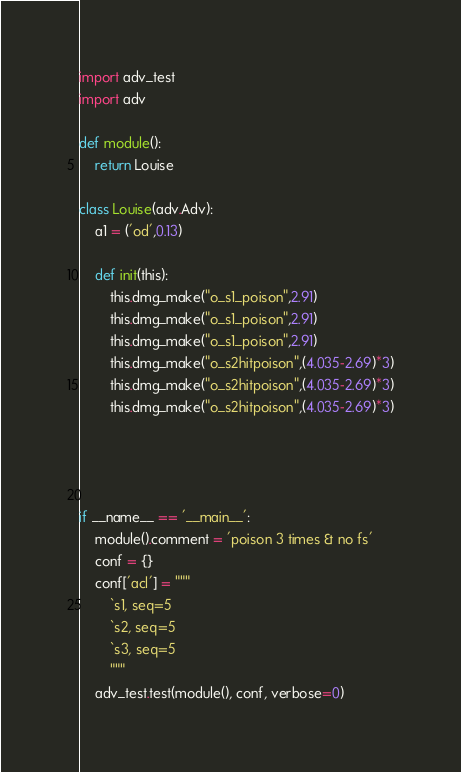<code> <loc_0><loc_0><loc_500><loc_500><_Python_>import adv_test
import adv

def module():
    return Louise

class Louise(adv.Adv):
    a1 = ('od',0.13)

    def init(this):
        this.dmg_make("o_s1_poison",2.91)
        this.dmg_make("o_s1_poison",2.91)
        this.dmg_make("o_s1_poison",2.91)
        this.dmg_make("o_s2hitpoison",(4.035-2.69)*3)
        this.dmg_make("o_s2hitpoison",(4.035-2.69)*3)
        this.dmg_make("o_s2hitpoison",(4.035-2.69)*3)




if __name__ == '__main__':
    module().comment = 'poison 3 times & no fs'
    conf = {}
    conf['acl'] = """
        `s1, seq=5
        `s2, seq=5
        `s3, seq=5
        """
    adv_test.test(module(), conf, verbose=0)
</code> 